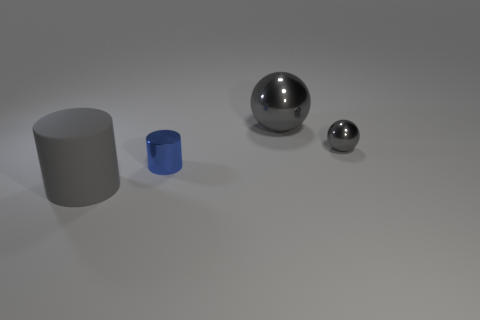The metal thing that is both left of the small gray sphere and behind the tiny cylinder is what color? The metallic object to the left of the small gray sphere and behind the tiny cylinder appears to be gray, which is indicative of its likely metallic material catching the soft lighting of the environment. 